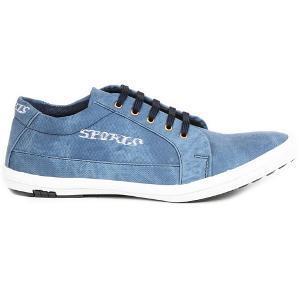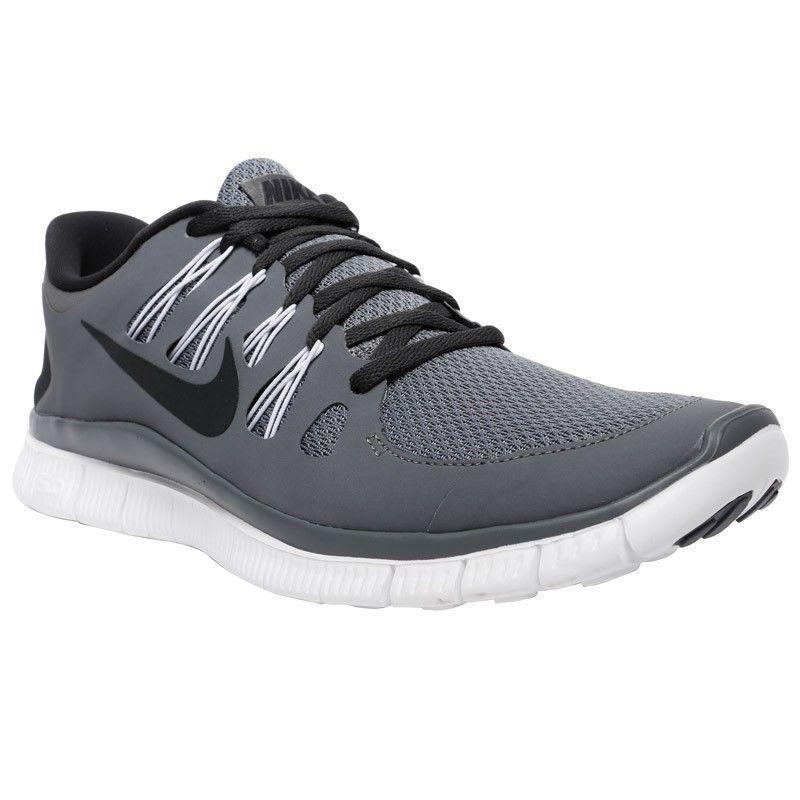The first image is the image on the left, the second image is the image on the right. Examine the images to the left and right. Is the description "all visible shoes have the toe side pointing towards the right" accurate? Answer yes or no. Yes. The first image is the image on the left, the second image is the image on the right. Evaluate the accuracy of this statement regarding the images: "All of the shoes are facing right.". Is it true? Answer yes or no. Yes. 